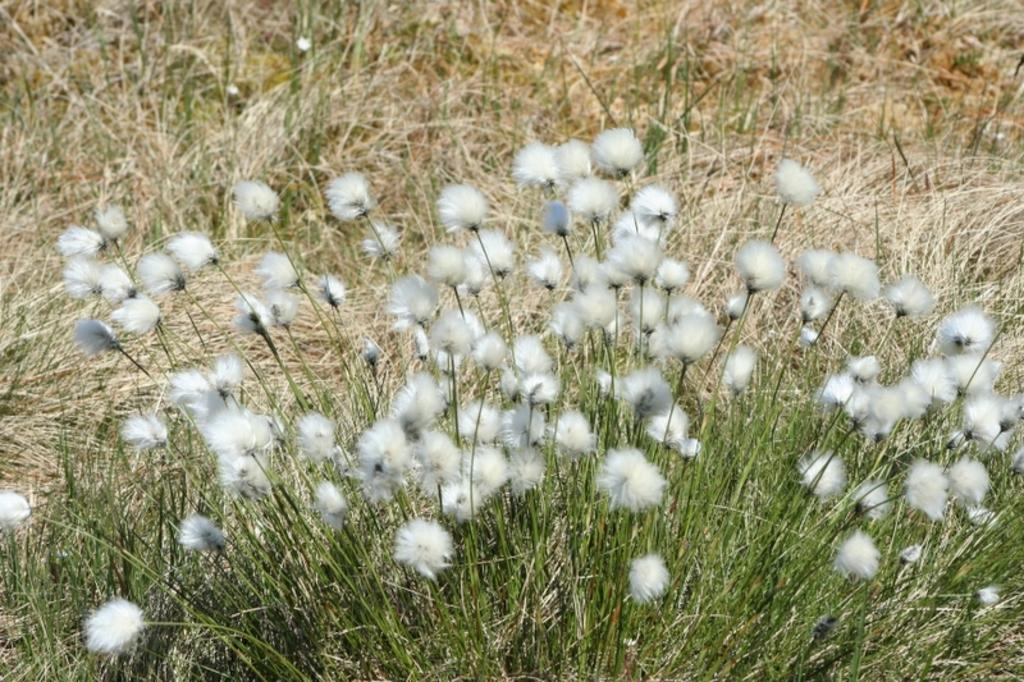What type of plants are in the image? There are cotton plants in the image. What is the color of the grass in the image? There is green grass and dry grass in the image. How many rifles can be seen in the image? There are no rifles present in the image. What time is displayed on the clock in the image? There is no clock present in the image. 